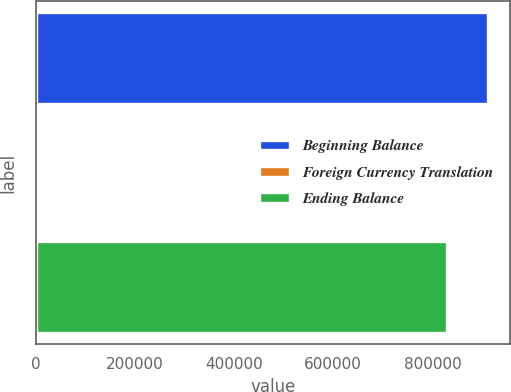Convert chart. <chart><loc_0><loc_0><loc_500><loc_500><bar_chart><fcel>Beginning Balance<fcel>Foreign Currency Translation<fcel>Ending Balance<nl><fcel>911797<fcel>1398<fcel>828523<nl></chart> 